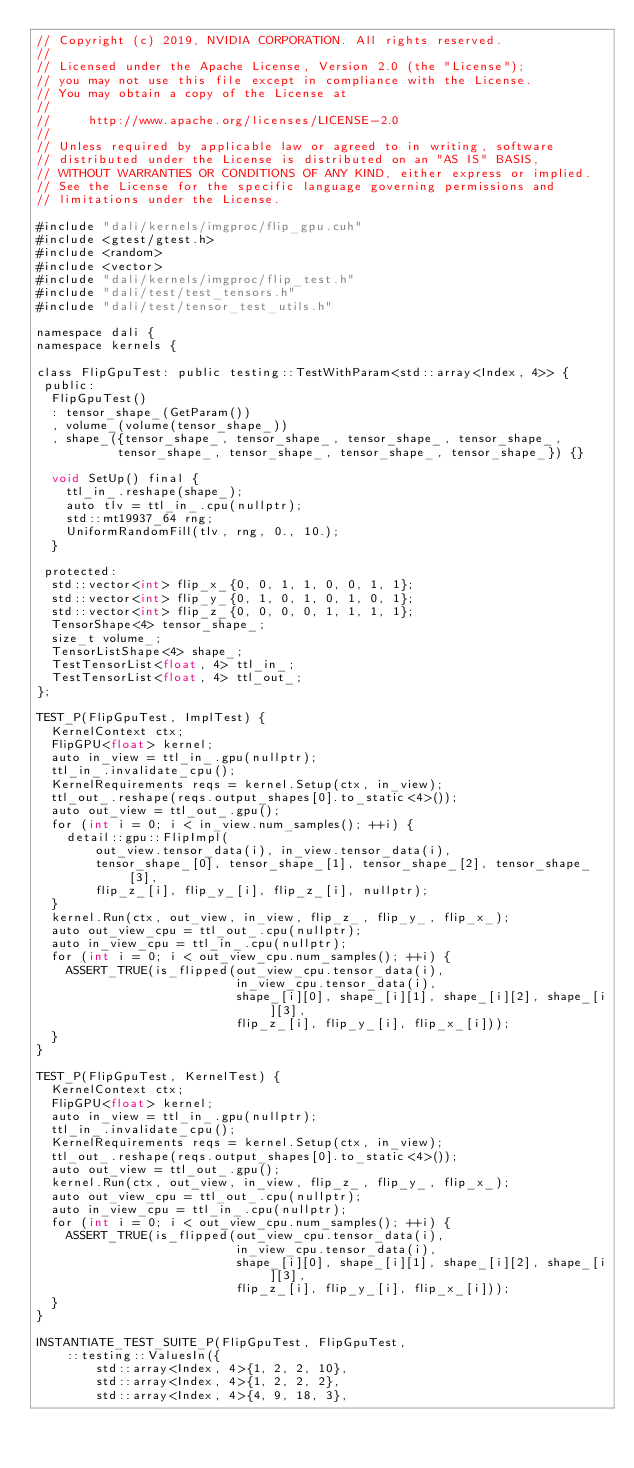Convert code to text. <code><loc_0><loc_0><loc_500><loc_500><_Cuda_>// Copyright (c) 2019, NVIDIA CORPORATION. All rights reserved.
//
// Licensed under the Apache License, Version 2.0 (the "License");
// you may not use this file except in compliance with the License.
// You may obtain a copy of the License at
//
//     http://www.apache.org/licenses/LICENSE-2.0
//
// Unless required by applicable law or agreed to in writing, software
// distributed under the License is distributed on an "AS IS" BASIS,
// WITHOUT WARRANTIES OR CONDITIONS OF ANY KIND, either express or implied.
// See the License for the specific language governing permissions and
// limitations under the License.

#include "dali/kernels/imgproc/flip_gpu.cuh"
#include <gtest/gtest.h>
#include <random>
#include <vector>
#include "dali/kernels/imgproc/flip_test.h"
#include "dali/test/test_tensors.h"
#include "dali/test/tensor_test_utils.h"

namespace dali {
namespace kernels {

class FlipGpuTest: public testing::TestWithParam<std::array<Index, 4>> {
 public:
  FlipGpuTest()
  : tensor_shape_(GetParam())
  , volume_(volume(tensor_shape_))
  , shape_({tensor_shape_, tensor_shape_, tensor_shape_, tensor_shape_,
           tensor_shape_, tensor_shape_, tensor_shape_, tensor_shape_}) {}

  void SetUp() final {
    ttl_in_.reshape(shape_);
    auto tlv = ttl_in_.cpu(nullptr);
    std::mt19937_64 rng;
    UniformRandomFill(tlv, rng, 0., 10.);
  }

 protected:
  std::vector<int> flip_x_{0, 0, 1, 1, 0, 0, 1, 1};
  std::vector<int> flip_y_{0, 1, 0, 1, 0, 1, 0, 1};
  std::vector<int> flip_z_{0, 0, 0, 0, 1, 1, 1, 1};
  TensorShape<4> tensor_shape_;
  size_t volume_;
  TensorListShape<4> shape_;
  TestTensorList<float, 4> ttl_in_;
  TestTensorList<float, 4> ttl_out_;
};

TEST_P(FlipGpuTest, ImplTest) {
  KernelContext ctx;
  FlipGPU<float> kernel;
  auto in_view = ttl_in_.gpu(nullptr);
  ttl_in_.invalidate_cpu();
  KernelRequirements reqs = kernel.Setup(ctx, in_view);
  ttl_out_.reshape(reqs.output_shapes[0].to_static<4>());
  auto out_view = ttl_out_.gpu();
  for (int i = 0; i < in_view.num_samples(); ++i) {
    detail::gpu::FlipImpl(
        out_view.tensor_data(i), in_view.tensor_data(i),
        tensor_shape_[0], tensor_shape_[1], tensor_shape_[2], tensor_shape_[3],
        flip_z_[i], flip_y_[i], flip_z_[i], nullptr);
  }
  kernel.Run(ctx, out_view, in_view, flip_z_, flip_y_, flip_x_);
  auto out_view_cpu = ttl_out_.cpu(nullptr);
  auto in_view_cpu = ttl_in_.cpu(nullptr);
  for (int i = 0; i < out_view_cpu.num_samples(); ++i) {
    ASSERT_TRUE(is_flipped(out_view_cpu.tensor_data(i),
                           in_view_cpu.tensor_data(i),
                           shape_[i][0], shape_[i][1], shape_[i][2], shape_[i][3],
                           flip_z_[i], flip_y_[i], flip_x_[i]));
  }
}

TEST_P(FlipGpuTest, KernelTest) {
  KernelContext ctx;
  FlipGPU<float> kernel;
  auto in_view = ttl_in_.gpu(nullptr);
  ttl_in_.invalidate_cpu();
  KernelRequirements reqs = kernel.Setup(ctx, in_view);
  ttl_out_.reshape(reqs.output_shapes[0].to_static<4>());
  auto out_view = ttl_out_.gpu();
  kernel.Run(ctx, out_view, in_view, flip_z_, flip_y_, flip_x_);
  auto out_view_cpu = ttl_out_.cpu(nullptr);
  auto in_view_cpu = ttl_in_.cpu(nullptr);
  for (int i = 0; i < out_view_cpu.num_samples(); ++i) {
    ASSERT_TRUE(is_flipped(out_view_cpu.tensor_data(i),
                           in_view_cpu.tensor_data(i),
                           shape_[i][0], shape_[i][1], shape_[i][2], shape_[i][3],
                           flip_z_[i], flip_y_[i], flip_x_[i]));
  }
}

INSTANTIATE_TEST_SUITE_P(FlipGpuTest, FlipGpuTest,
    ::testing::ValuesIn({
        std::array<Index, 4>{1, 2, 2, 10},
        std::array<Index, 4>{1, 2, 2, 2},
        std::array<Index, 4>{4, 9, 18, 3},</code> 